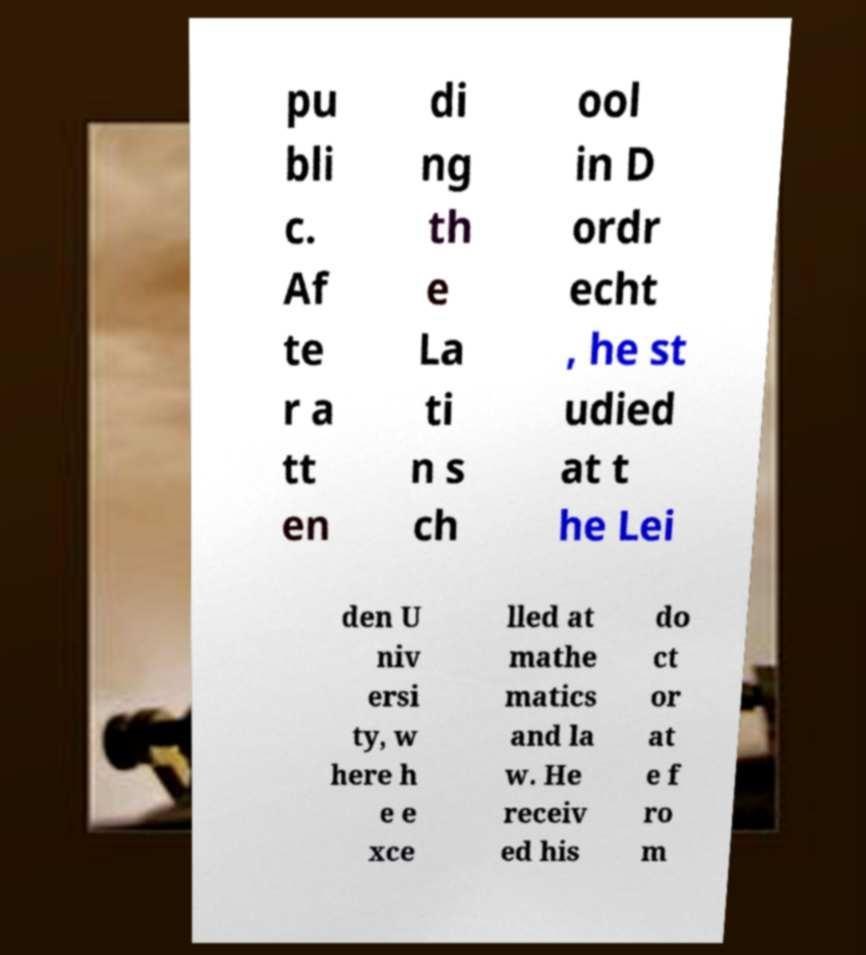For documentation purposes, I need the text within this image transcribed. Could you provide that? pu bli c. Af te r a tt en di ng th e La ti n s ch ool in D ordr echt , he st udied at t he Lei den U niv ersi ty, w here h e e xce lled at mathe matics and la w. He receiv ed his do ct or at e f ro m 